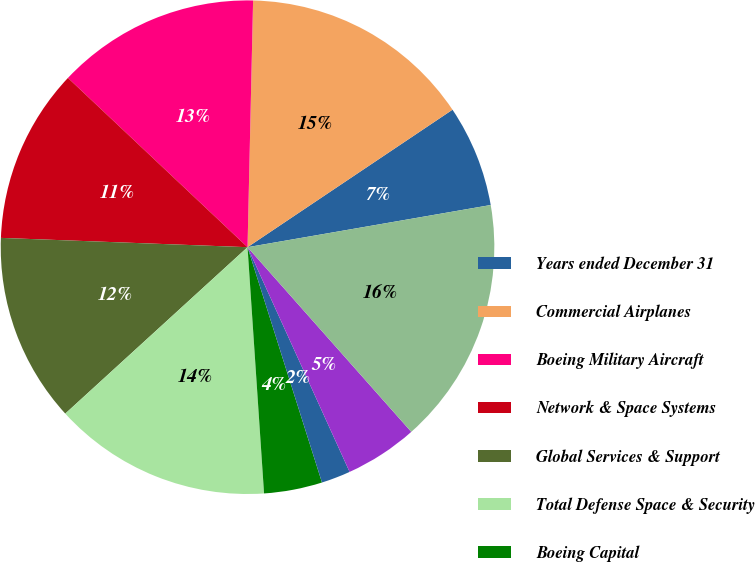Convert chart. <chart><loc_0><loc_0><loc_500><loc_500><pie_chart><fcel>Years ended December 31<fcel>Commercial Airplanes<fcel>Boeing Military Aircraft<fcel>Network & Space Systems<fcel>Global Services & Support<fcel>Total Defense Space & Security<fcel>Boeing Capital<fcel>Other segment<fcel>Unallocated items and<fcel>Total revenues<nl><fcel>6.67%<fcel>15.24%<fcel>13.33%<fcel>11.43%<fcel>12.38%<fcel>14.29%<fcel>3.81%<fcel>1.91%<fcel>4.76%<fcel>16.19%<nl></chart> 